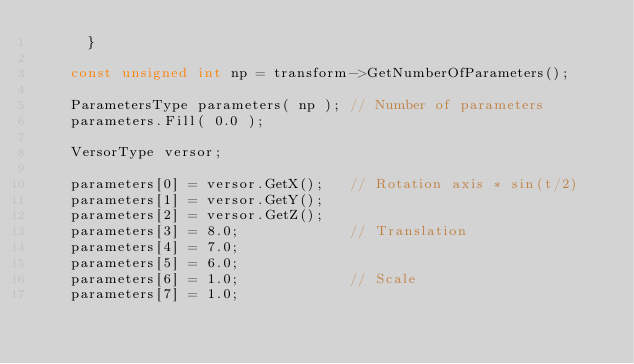Convert code to text. <code><loc_0><loc_0><loc_500><loc_500><_C++_>      }

    const unsigned int np = transform->GetNumberOfParameters();

    ParametersType parameters( np ); // Number of parameters
    parameters.Fill( 0.0 );

    VersorType versor;

    parameters[0] = versor.GetX();   // Rotation axis * sin(t/2)
    parameters[1] = versor.GetY();
    parameters[2] = versor.GetZ();
    parameters[3] = 8.0;             // Translation
    parameters[4] = 7.0;
    parameters[5] = 6.0;
    parameters[6] = 1.0;             // Scale
    parameters[7] = 1.0;</code> 